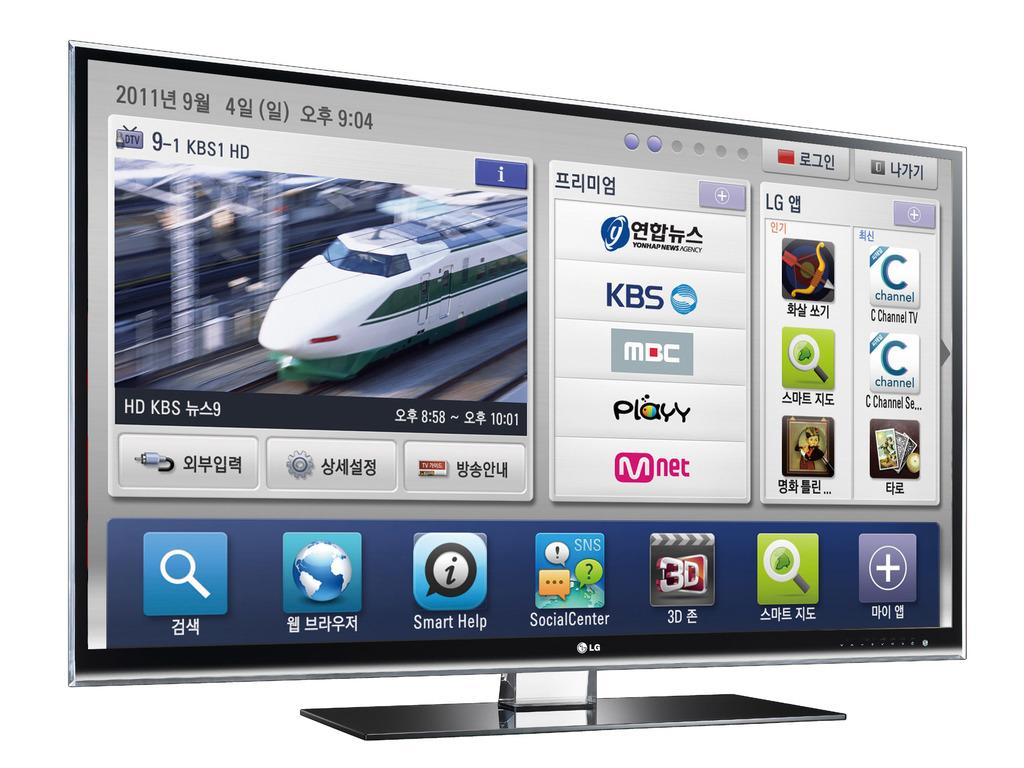Provide a one-sentence caption for the provided image. Computer screen displaying Your app/news agency showing KBS and Mnet. 